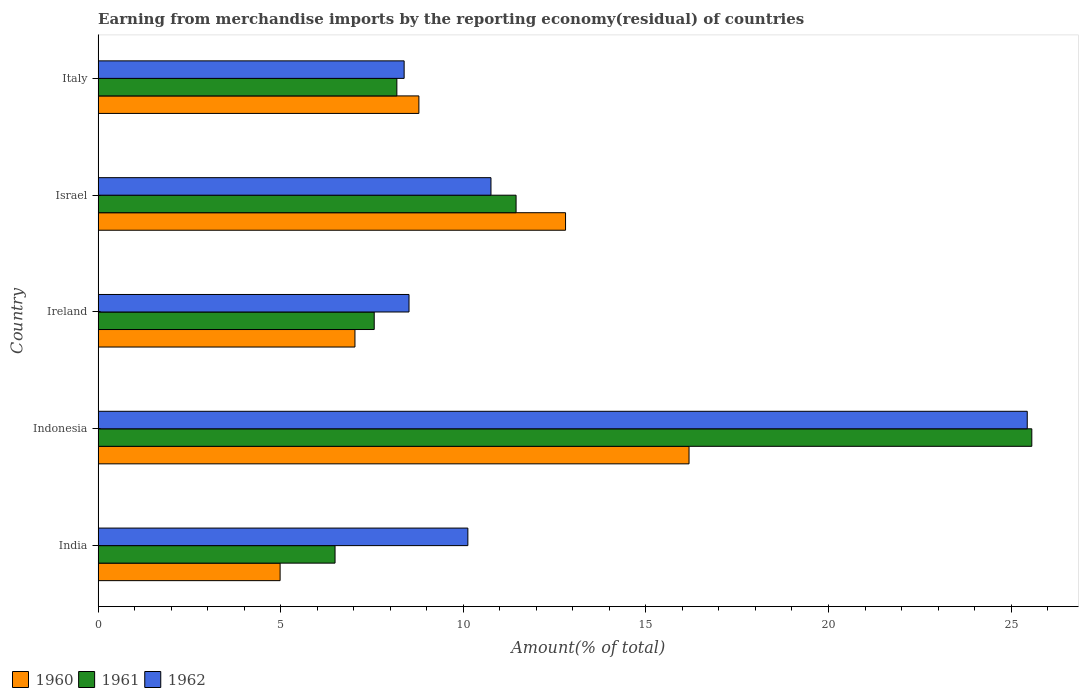How many groups of bars are there?
Ensure brevity in your answer.  5. Are the number of bars per tick equal to the number of legend labels?
Offer a very short reply. Yes. How many bars are there on the 2nd tick from the bottom?
Ensure brevity in your answer.  3. What is the label of the 4th group of bars from the top?
Your answer should be very brief. Indonesia. What is the percentage of amount earned from merchandise imports in 1961 in Ireland?
Offer a terse response. 7.56. Across all countries, what is the maximum percentage of amount earned from merchandise imports in 1960?
Provide a short and direct response. 16.18. Across all countries, what is the minimum percentage of amount earned from merchandise imports in 1962?
Your response must be concise. 8.38. What is the total percentage of amount earned from merchandise imports in 1961 in the graph?
Make the answer very short. 59.24. What is the difference between the percentage of amount earned from merchandise imports in 1961 in Indonesia and that in Israel?
Ensure brevity in your answer.  14.12. What is the difference between the percentage of amount earned from merchandise imports in 1961 in Italy and the percentage of amount earned from merchandise imports in 1960 in Indonesia?
Keep it short and to the point. -8. What is the average percentage of amount earned from merchandise imports in 1961 per country?
Provide a succinct answer. 11.85. What is the difference between the percentage of amount earned from merchandise imports in 1962 and percentage of amount earned from merchandise imports in 1960 in Ireland?
Provide a succinct answer. 1.48. In how many countries, is the percentage of amount earned from merchandise imports in 1962 greater than 17 %?
Offer a terse response. 1. What is the ratio of the percentage of amount earned from merchandise imports in 1962 in Indonesia to that in Israel?
Provide a short and direct response. 2.37. What is the difference between the highest and the second highest percentage of amount earned from merchandise imports in 1960?
Provide a short and direct response. 3.38. What is the difference between the highest and the lowest percentage of amount earned from merchandise imports in 1961?
Provide a short and direct response. 19.08. What does the 1st bar from the top in Ireland represents?
Provide a succinct answer. 1962. What does the 2nd bar from the bottom in Italy represents?
Your answer should be very brief. 1961. Is it the case that in every country, the sum of the percentage of amount earned from merchandise imports in 1960 and percentage of amount earned from merchandise imports in 1962 is greater than the percentage of amount earned from merchandise imports in 1961?
Give a very brief answer. Yes. Are all the bars in the graph horizontal?
Ensure brevity in your answer.  Yes. What is the difference between two consecutive major ticks on the X-axis?
Make the answer very short. 5. Does the graph contain any zero values?
Offer a terse response. No. Where does the legend appear in the graph?
Your answer should be compact. Bottom left. How are the legend labels stacked?
Provide a short and direct response. Horizontal. What is the title of the graph?
Ensure brevity in your answer.  Earning from merchandise imports by the reporting economy(residual) of countries. What is the label or title of the X-axis?
Offer a terse response. Amount(% of total). What is the label or title of the Y-axis?
Your answer should be compact. Country. What is the Amount(% of total) of 1960 in India?
Ensure brevity in your answer.  4.98. What is the Amount(% of total) in 1961 in India?
Provide a short and direct response. 6.49. What is the Amount(% of total) of 1962 in India?
Your answer should be very brief. 10.12. What is the Amount(% of total) of 1960 in Indonesia?
Your answer should be compact. 16.18. What is the Amount(% of total) in 1961 in Indonesia?
Make the answer very short. 25.57. What is the Amount(% of total) in 1962 in Indonesia?
Provide a short and direct response. 25.44. What is the Amount(% of total) in 1960 in Ireland?
Keep it short and to the point. 7.03. What is the Amount(% of total) of 1961 in Ireland?
Ensure brevity in your answer.  7.56. What is the Amount(% of total) of 1962 in Ireland?
Your answer should be very brief. 8.51. What is the Amount(% of total) of 1960 in Israel?
Provide a short and direct response. 12.8. What is the Amount(% of total) in 1961 in Israel?
Provide a short and direct response. 11.45. What is the Amount(% of total) of 1962 in Israel?
Provide a short and direct response. 10.76. What is the Amount(% of total) in 1960 in Italy?
Your answer should be very brief. 8.78. What is the Amount(% of total) of 1961 in Italy?
Your answer should be very brief. 8.18. What is the Amount(% of total) in 1962 in Italy?
Your answer should be compact. 8.38. Across all countries, what is the maximum Amount(% of total) in 1960?
Provide a short and direct response. 16.18. Across all countries, what is the maximum Amount(% of total) of 1961?
Provide a succinct answer. 25.57. Across all countries, what is the maximum Amount(% of total) of 1962?
Offer a very short reply. 25.44. Across all countries, what is the minimum Amount(% of total) in 1960?
Give a very brief answer. 4.98. Across all countries, what is the minimum Amount(% of total) of 1961?
Keep it short and to the point. 6.49. Across all countries, what is the minimum Amount(% of total) in 1962?
Ensure brevity in your answer.  8.38. What is the total Amount(% of total) of 1960 in the graph?
Your answer should be compact. 49.78. What is the total Amount(% of total) in 1961 in the graph?
Ensure brevity in your answer.  59.24. What is the total Amount(% of total) of 1962 in the graph?
Your answer should be compact. 63.22. What is the difference between the Amount(% of total) in 1960 in India and that in Indonesia?
Keep it short and to the point. -11.2. What is the difference between the Amount(% of total) of 1961 in India and that in Indonesia?
Keep it short and to the point. -19.08. What is the difference between the Amount(% of total) in 1962 in India and that in Indonesia?
Your answer should be compact. -15.32. What is the difference between the Amount(% of total) of 1960 in India and that in Ireland?
Your answer should be very brief. -2.05. What is the difference between the Amount(% of total) of 1961 in India and that in Ireland?
Make the answer very short. -1.07. What is the difference between the Amount(% of total) of 1962 in India and that in Ireland?
Offer a very short reply. 1.61. What is the difference between the Amount(% of total) in 1960 in India and that in Israel?
Your response must be concise. -7.82. What is the difference between the Amount(% of total) of 1961 in India and that in Israel?
Your answer should be compact. -4.96. What is the difference between the Amount(% of total) of 1962 in India and that in Israel?
Provide a succinct answer. -0.63. What is the difference between the Amount(% of total) of 1960 in India and that in Italy?
Offer a very short reply. -3.8. What is the difference between the Amount(% of total) of 1961 in India and that in Italy?
Provide a succinct answer. -1.69. What is the difference between the Amount(% of total) in 1962 in India and that in Italy?
Your answer should be very brief. 1.74. What is the difference between the Amount(% of total) in 1960 in Indonesia and that in Ireland?
Your answer should be compact. 9.15. What is the difference between the Amount(% of total) of 1961 in Indonesia and that in Ireland?
Ensure brevity in your answer.  18.01. What is the difference between the Amount(% of total) of 1962 in Indonesia and that in Ireland?
Give a very brief answer. 16.93. What is the difference between the Amount(% of total) in 1960 in Indonesia and that in Israel?
Your response must be concise. 3.38. What is the difference between the Amount(% of total) in 1961 in Indonesia and that in Israel?
Offer a terse response. 14.12. What is the difference between the Amount(% of total) in 1962 in Indonesia and that in Israel?
Ensure brevity in your answer.  14.69. What is the difference between the Amount(% of total) of 1960 in Indonesia and that in Italy?
Ensure brevity in your answer.  7.4. What is the difference between the Amount(% of total) of 1961 in Indonesia and that in Italy?
Give a very brief answer. 17.39. What is the difference between the Amount(% of total) in 1962 in Indonesia and that in Italy?
Provide a succinct answer. 17.06. What is the difference between the Amount(% of total) of 1960 in Ireland and that in Israel?
Make the answer very short. -5.77. What is the difference between the Amount(% of total) of 1961 in Ireland and that in Israel?
Keep it short and to the point. -3.88. What is the difference between the Amount(% of total) of 1962 in Ireland and that in Israel?
Keep it short and to the point. -2.24. What is the difference between the Amount(% of total) in 1960 in Ireland and that in Italy?
Provide a succinct answer. -1.75. What is the difference between the Amount(% of total) of 1961 in Ireland and that in Italy?
Your response must be concise. -0.62. What is the difference between the Amount(% of total) in 1962 in Ireland and that in Italy?
Offer a very short reply. 0.13. What is the difference between the Amount(% of total) in 1960 in Israel and that in Italy?
Provide a short and direct response. 4.02. What is the difference between the Amount(% of total) in 1961 in Israel and that in Italy?
Your answer should be compact. 3.26. What is the difference between the Amount(% of total) in 1962 in Israel and that in Italy?
Provide a succinct answer. 2.38. What is the difference between the Amount(% of total) in 1960 in India and the Amount(% of total) in 1961 in Indonesia?
Your answer should be compact. -20.58. What is the difference between the Amount(% of total) in 1960 in India and the Amount(% of total) in 1962 in Indonesia?
Your answer should be compact. -20.46. What is the difference between the Amount(% of total) of 1961 in India and the Amount(% of total) of 1962 in Indonesia?
Your answer should be very brief. -18.95. What is the difference between the Amount(% of total) in 1960 in India and the Amount(% of total) in 1961 in Ireland?
Provide a succinct answer. -2.58. What is the difference between the Amount(% of total) of 1960 in India and the Amount(% of total) of 1962 in Ireland?
Your answer should be compact. -3.53. What is the difference between the Amount(% of total) in 1961 in India and the Amount(% of total) in 1962 in Ireland?
Give a very brief answer. -2.03. What is the difference between the Amount(% of total) in 1960 in India and the Amount(% of total) in 1961 in Israel?
Offer a terse response. -6.46. What is the difference between the Amount(% of total) in 1960 in India and the Amount(% of total) in 1962 in Israel?
Your response must be concise. -5.77. What is the difference between the Amount(% of total) in 1961 in India and the Amount(% of total) in 1962 in Israel?
Offer a terse response. -4.27. What is the difference between the Amount(% of total) in 1960 in India and the Amount(% of total) in 1961 in Italy?
Your response must be concise. -3.2. What is the difference between the Amount(% of total) of 1960 in India and the Amount(% of total) of 1962 in Italy?
Provide a succinct answer. -3.4. What is the difference between the Amount(% of total) of 1961 in India and the Amount(% of total) of 1962 in Italy?
Your response must be concise. -1.89. What is the difference between the Amount(% of total) in 1960 in Indonesia and the Amount(% of total) in 1961 in Ireland?
Provide a short and direct response. 8.62. What is the difference between the Amount(% of total) of 1960 in Indonesia and the Amount(% of total) of 1962 in Ireland?
Your answer should be compact. 7.67. What is the difference between the Amount(% of total) in 1961 in Indonesia and the Amount(% of total) in 1962 in Ireland?
Make the answer very short. 17.05. What is the difference between the Amount(% of total) of 1960 in Indonesia and the Amount(% of total) of 1961 in Israel?
Your answer should be very brief. 4.74. What is the difference between the Amount(% of total) in 1960 in Indonesia and the Amount(% of total) in 1962 in Israel?
Provide a short and direct response. 5.42. What is the difference between the Amount(% of total) in 1961 in Indonesia and the Amount(% of total) in 1962 in Israel?
Keep it short and to the point. 14.81. What is the difference between the Amount(% of total) in 1960 in Indonesia and the Amount(% of total) in 1961 in Italy?
Your answer should be very brief. 8. What is the difference between the Amount(% of total) of 1960 in Indonesia and the Amount(% of total) of 1962 in Italy?
Your answer should be very brief. 7.8. What is the difference between the Amount(% of total) in 1961 in Indonesia and the Amount(% of total) in 1962 in Italy?
Ensure brevity in your answer.  17.19. What is the difference between the Amount(% of total) in 1960 in Ireland and the Amount(% of total) in 1961 in Israel?
Make the answer very short. -4.41. What is the difference between the Amount(% of total) in 1960 in Ireland and the Amount(% of total) in 1962 in Israel?
Offer a terse response. -3.72. What is the difference between the Amount(% of total) of 1961 in Ireland and the Amount(% of total) of 1962 in Israel?
Make the answer very short. -3.2. What is the difference between the Amount(% of total) of 1960 in Ireland and the Amount(% of total) of 1961 in Italy?
Offer a very short reply. -1.15. What is the difference between the Amount(% of total) of 1960 in Ireland and the Amount(% of total) of 1962 in Italy?
Your answer should be compact. -1.35. What is the difference between the Amount(% of total) of 1961 in Ireland and the Amount(% of total) of 1962 in Italy?
Offer a terse response. -0.82. What is the difference between the Amount(% of total) of 1960 in Israel and the Amount(% of total) of 1961 in Italy?
Provide a succinct answer. 4.62. What is the difference between the Amount(% of total) in 1960 in Israel and the Amount(% of total) in 1962 in Italy?
Your response must be concise. 4.42. What is the difference between the Amount(% of total) of 1961 in Israel and the Amount(% of total) of 1962 in Italy?
Your answer should be very brief. 3.06. What is the average Amount(% of total) of 1960 per country?
Give a very brief answer. 9.96. What is the average Amount(% of total) of 1961 per country?
Ensure brevity in your answer.  11.85. What is the average Amount(% of total) in 1962 per country?
Your answer should be very brief. 12.64. What is the difference between the Amount(% of total) in 1960 and Amount(% of total) in 1961 in India?
Offer a very short reply. -1.5. What is the difference between the Amount(% of total) of 1960 and Amount(% of total) of 1962 in India?
Offer a terse response. -5.14. What is the difference between the Amount(% of total) of 1961 and Amount(% of total) of 1962 in India?
Your answer should be very brief. -3.64. What is the difference between the Amount(% of total) in 1960 and Amount(% of total) in 1961 in Indonesia?
Give a very brief answer. -9.39. What is the difference between the Amount(% of total) of 1960 and Amount(% of total) of 1962 in Indonesia?
Offer a very short reply. -9.26. What is the difference between the Amount(% of total) in 1961 and Amount(% of total) in 1962 in Indonesia?
Your answer should be compact. 0.12. What is the difference between the Amount(% of total) of 1960 and Amount(% of total) of 1961 in Ireland?
Your response must be concise. -0.53. What is the difference between the Amount(% of total) in 1960 and Amount(% of total) in 1962 in Ireland?
Offer a very short reply. -1.48. What is the difference between the Amount(% of total) of 1961 and Amount(% of total) of 1962 in Ireland?
Your answer should be compact. -0.95. What is the difference between the Amount(% of total) of 1960 and Amount(% of total) of 1961 in Israel?
Your response must be concise. 1.35. What is the difference between the Amount(% of total) of 1960 and Amount(% of total) of 1962 in Israel?
Offer a terse response. 2.04. What is the difference between the Amount(% of total) in 1961 and Amount(% of total) in 1962 in Israel?
Provide a succinct answer. 0.69. What is the difference between the Amount(% of total) of 1960 and Amount(% of total) of 1961 in Italy?
Ensure brevity in your answer.  0.6. What is the difference between the Amount(% of total) in 1960 and Amount(% of total) in 1962 in Italy?
Ensure brevity in your answer.  0.4. What is the difference between the Amount(% of total) of 1961 and Amount(% of total) of 1962 in Italy?
Provide a succinct answer. -0.2. What is the ratio of the Amount(% of total) in 1960 in India to that in Indonesia?
Your response must be concise. 0.31. What is the ratio of the Amount(% of total) in 1961 in India to that in Indonesia?
Offer a terse response. 0.25. What is the ratio of the Amount(% of total) of 1962 in India to that in Indonesia?
Keep it short and to the point. 0.4. What is the ratio of the Amount(% of total) of 1960 in India to that in Ireland?
Give a very brief answer. 0.71. What is the ratio of the Amount(% of total) in 1961 in India to that in Ireland?
Keep it short and to the point. 0.86. What is the ratio of the Amount(% of total) of 1962 in India to that in Ireland?
Give a very brief answer. 1.19. What is the ratio of the Amount(% of total) in 1960 in India to that in Israel?
Provide a short and direct response. 0.39. What is the ratio of the Amount(% of total) in 1961 in India to that in Israel?
Ensure brevity in your answer.  0.57. What is the ratio of the Amount(% of total) of 1960 in India to that in Italy?
Provide a succinct answer. 0.57. What is the ratio of the Amount(% of total) of 1961 in India to that in Italy?
Your answer should be compact. 0.79. What is the ratio of the Amount(% of total) in 1962 in India to that in Italy?
Provide a short and direct response. 1.21. What is the ratio of the Amount(% of total) in 1960 in Indonesia to that in Ireland?
Your response must be concise. 2.3. What is the ratio of the Amount(% of total) of 1961 in Indonesia to that in Ireland?
Your answer should be very brief. 3.38. What is the ratio of the Amount(% of total) in 1962 in Indonesia to that in Ireland?
Make the answer very short. 2.99. What is the ratio of the Amount(% of total) in 1960 in Indonesia to that in Israel?
Provide a short and direct response. 1.26. What is the ratio of the Amount(% of total) of 1961 in Indonesia to that in Israel?
Keep it short and to the point. 2.23. What is the ratio of the Amount(% of total) of 1962 in Indonesia to that in Israel?
Your response must be concise. 2.37. What is the ratio of the Amount(% of total) in 1960 in Indonesia to that in Italy?
Your answer should be compact. 1.84. What is the ratio of the Amount(% of total) of 1961 in Indonesia to that in Italy?
Keep it short and to the point. 3.13. What is the ratio of the Amount(% of total) in 1962 in Indonesia to that in Italy?
Keep it short and to the point. 3.04. What is the ratio of the Amount(% of total) of 1960 in Ireland to that in Israel?
Your answer should be very brief. 0.55. What is the ratio of the Amount(% of total) in 1961 in Ireland to that in Israel?
Keep it short and to the point. 0.66. What is the ratio of the Amount(% of total) of 1962 in Ireland to that in Israel?
Give a very brief answer. 0.79. What is the ratio of the Amount(% of total) in 1960 in Ireland to that in Italy?
Keep it short and to the point. 0.8. What is the ratio of the Amount(% of total) of 1961 in Ireland to that in Italy?
Your answer should be compact. 0.92. What is the ratio of the Amount(% of total) in 1962 in Ireland to that in Italy?
Offer a terse response. 1.02. What is the ratio of the Amount(% of total) in 1960 in Israel to that in Italy?
Provide a short and direct response. 1.46. What is the ratio of the Amount(% of total) of 1961 in Israel to that in Italy?
Your response must be concise. 1.4. What is the ratio of the Amount(% of total) of 1962 in Israel to that in Italy?
Your answer should be very brief. 1.28. What is the difference between the highest and the second highest Amount(% of total) of 1960?
Ensure brevity in your answer.  3.38. What is the difference between the highest and the second highest Amount(% of total) in 1961?
Your answer should be very brief. 14.12. What is the difference between the highest and the second highest Amount(% of total) of 1962?
Your response must be concise. 14.69. What is the difference between the highest and the lowest Amount(% of total) of 1960?
Make the answer very short. 11.2. What is the difference between the highest and the lowest Amount(% of total) in 1961?
Keep it short and to the point. 19.08. What is the difference between the highest and the lowest Amount(% of total) of 1962?
Provide a short and direct response. 17.06. 